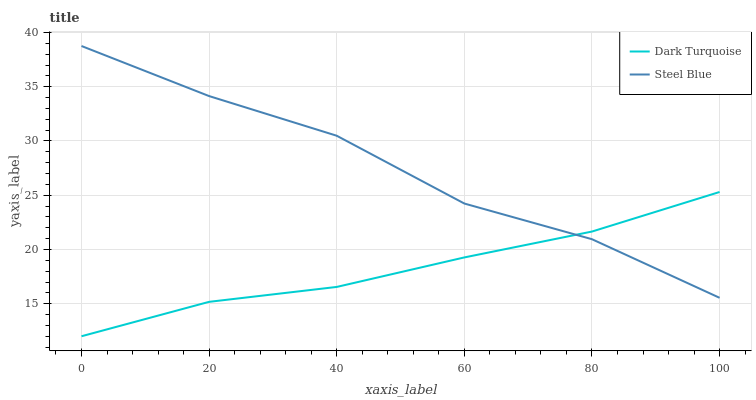Does Steel Blue have the minimum area under the curve?
Answer yes or no. No. Is Steel Blue the smoothest?
Answer yes or no. No. Does Steel Blue have the lowest value?
Answer yes or no. No. 